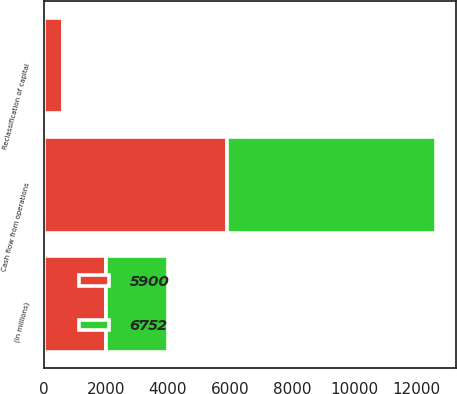<chart> <loc_0><loc_0><loc_500><loc_500><stacked_bar_chart><ecel><fcel>(in millions)<fcel>Cash flow from operations<fcel>Reclassification of capital<nl><fcel>6752<fcel>2008<fcel>6752<fcel>30<nl><fcel>5900<fcel>2007<fcel>5900<fcel>621<nl></chart> 